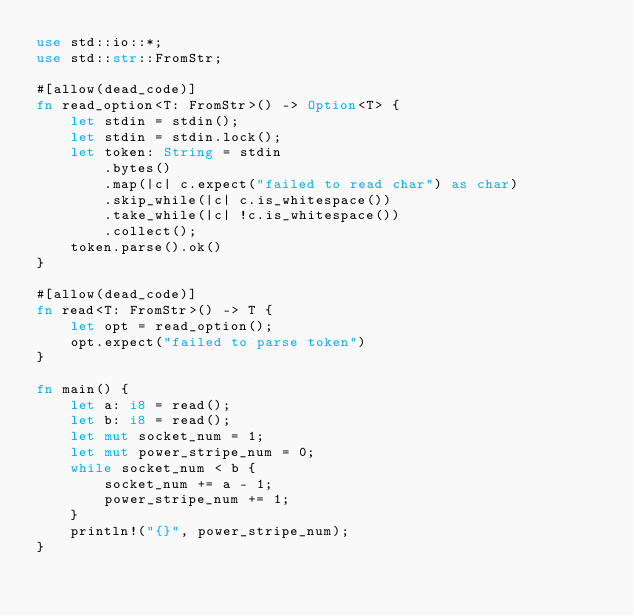<code> <loc_0><loc_0><loc_500><loc_500><_Rust_>use std::io::*;
use std::str::FromStr;

#[allow(dead_code)]
fn read_option<T: FromStr>() -> Option<T> {
    let stdin = stdin();
    let stdin = stdin.lock();
    let token: String = stdin
        .bytes()
        .map(|c| c.expect("failed to read char") as char)
        .skip_while(|c| c.is_whitespace())
        .take_while(|c| !c.is_whitespace())
        .collect();
    token.parse().ok()
}

#[allow(dead_code)]
fn read<T: FromStr>() -> T {
    let opt = read_option();
    opt.expect("failed to parse token")
}

fn main() {
    let a: i8 = read();
    let b: i8 = read();
    let mut socket_num = 1;
    let mut power_stripe_num = 0;
    while socket_num < b {
        socket_num += a - 1;
        power_stripe_num += 1;
    }
    println!("{}", power_stripe_num);
}
</code> 